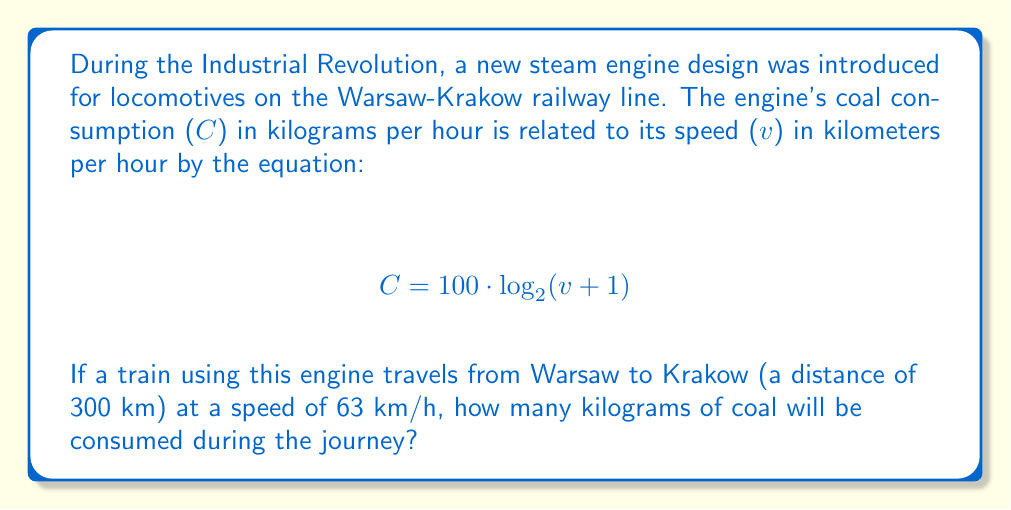Give your solution to this math problem. Let's approach this problem step by step:

1) First, we need to calculate the duration of the journey:
   Time = Distance / Speed
   $$ t = \frac{300 \text{ km}}{63 \text{ km/h}} = 4.76 \text{ hours} $$

2) Now, we need to calculate the coal consumption rate using the given equation:
   $$ C = 100 \cdot \log_2(v+1) $$
   $$ C = 100 \cdot \log_2(63+1) $$
   $$ C = 100 \cdot \log_2(64) $$

3) Simplify:
   $$ C = 100 \cdot 6 = 600 \text{ kg/h} $$

4) Finally, we calculate the total coal consumption for the journey:
   Total Coal = Rate × Time
   $$ \text{Total Coal} = 600 \text{ kg/h} \times 4.76 \text{ h} = 2856 \text{ kg} $$

Therefore, the train will consume 2856 kg of coal during the journey from Warsaw to Krakow.
Answer: 2856 kg 